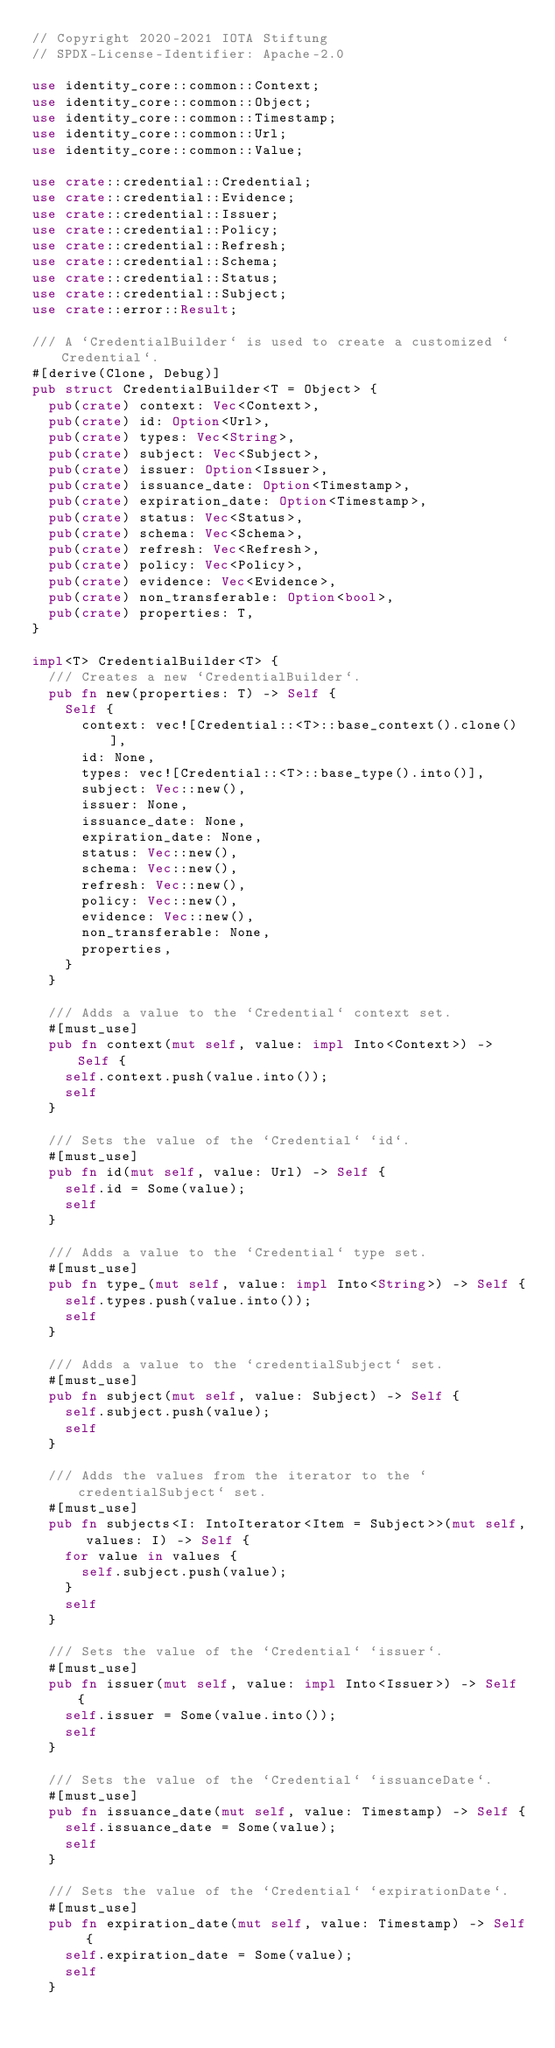<code> <loc_0><loc_0><loc_500><loc_500><_Rust_>// Copyright 2020-2021 IOTA Stiftung
// SPDX-License-Identifier: Apache-2.0

use identity_core::common::Context;
use identity_core::common::Object;
use identity_core::common::Timestamp;
use identity_core::common::Url;
use identity_core::common::Value;

use crate::credential::Credential;
use crate::credential::Evidence;
use crate::credential::Issuer;
use crate::credential::Policy;
use crate::credential::Refresh;
use crate::credential::Schema;
use crate::credential::Status;
use crate::credential::Subject;
use crate::error::Result;

/// A `CredentialBuilder` is used to create a customized `Credential`.
#[derive(Clone, Debug)]
pub struct CredentialBuilder<T = Object> {
  pub(crate) context: Vec<Context>,
  pub(crate) id: Option<Url>,
  pub(crate) types: Vec<String>,
  pub(crate) subject: Vec<Subject>,
  pub(crate) issuer: Option<Issuer>,
  pub(crate) issuance_date: Option<Timestamp>,
  pub(crate) expiration_date: Option<Timestamp>,
  pub(crate) status: Vec<Status>,
  pub(crate) schema: Vec<Schema>,
  pub(crate) refresh: Vec<Refresh>,
  pub(crate) policy: Vec<Policy>,
  pub(crate) evidence: Vec<Evidence>,
  pub(crate) non_transferable: Option<bool>,
  pub(crate) properties: T,
}

impl<T> CredentialBuilder<T> {
  /// Creates a new `CredentialBuilder`.
  pub fn new(properties: T) -> Self {
    Self {
      context: vec![Credential::<T>::base_context().clone()],
      id: None,
      types: vec![Credential::<T>::base_type().into()],
      subject: Vec::new(),
      issuer: None,
      issuance_date: None,
      expiration_date: None,
      status: Vec::new(),
      schema: Vec::new(),
      refresh: Vec::new(),
      policy: Vec::new(),
      evidence: Vec::new(),
      non_transferable: None,
      properties,
    }
  }

  /// Adds a value to the `Credential` context set.
  #[must_use]
  pub fn context(mut self, value: impl Into<Context>) -> Self {
    self.context.push(value.into());
    self
  }

  /// Sets the value of the `Credential` `id`.
  #[must_use]
  pub fn id(mut self, value: Url) -> Self {
    self.id = Some(value);
    self
  }

  /// Adds a value to the `Credential` type set.
  #[must_use]
  pub fn type_(mut self, value: impl Into<String>) -> Self {
    self.types.push(value.into());
    self
  }

  /// Adds a value to the `credentialSubject` set.
  #[must_use]
  pub fn subject(mut self, value: Subject) -> Self {
    self.subject.push(value);
    self
  }

  /// Adds the values from the iterator to the `credentialSubject` set.
  #[must_use]
  pub fn subjects<I: IntoIterator<Item = Subject>>(mut self, values: I) -> Self {
    for value in values {
      self.subject.push(value);
    }
    self
  }

  /// Sets the value of the `Credential` `issuer`.
  #[must_use]
  pub fn issuer(mut self, value: impl Into<Issuer>) -> Self {
    self.issuer = Some(value.into());
    self
  }

  /// Sets the value of the `Credential` `issuanceDate`.
  #[must_use]
  pub fn issuance_date(mut self, value: Timestamp) -> Self {
    self.issuance_date = Some(value);
    self
  }

  /// Sets the value of the `Credential` `expirationDate`.
  #[must_use]
  pub fn expiration_date(mut self, value: Timestamp) -> Self {
    self.expiration_date = Some(value);
    self
  }
</code> 